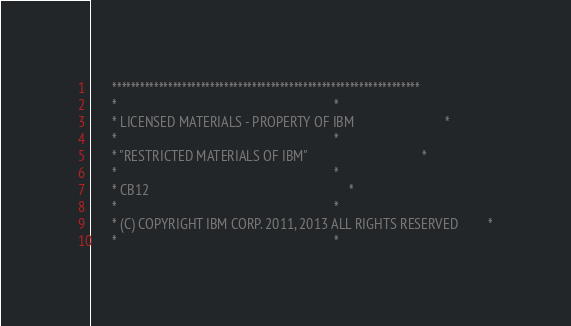Convert code to text. <code><loc_0><loc_0><loc_500><loc_500><_COBOL_>      ******************************************************************
      *                                                                *
      * LICENSED MATERIALS - PROPERTY OF IBM                           *
      *                                                                *
      * "RESTRICTED MATERIALS OF IBM"                                  *
      *                                                                *
      * CB12                                                           *
      *                                                                *
      * (C) COPYRIGHT IBM CORP. 2011, 2013 ALL RIGHTS RESERVED         *
      *                                                                *</code> 